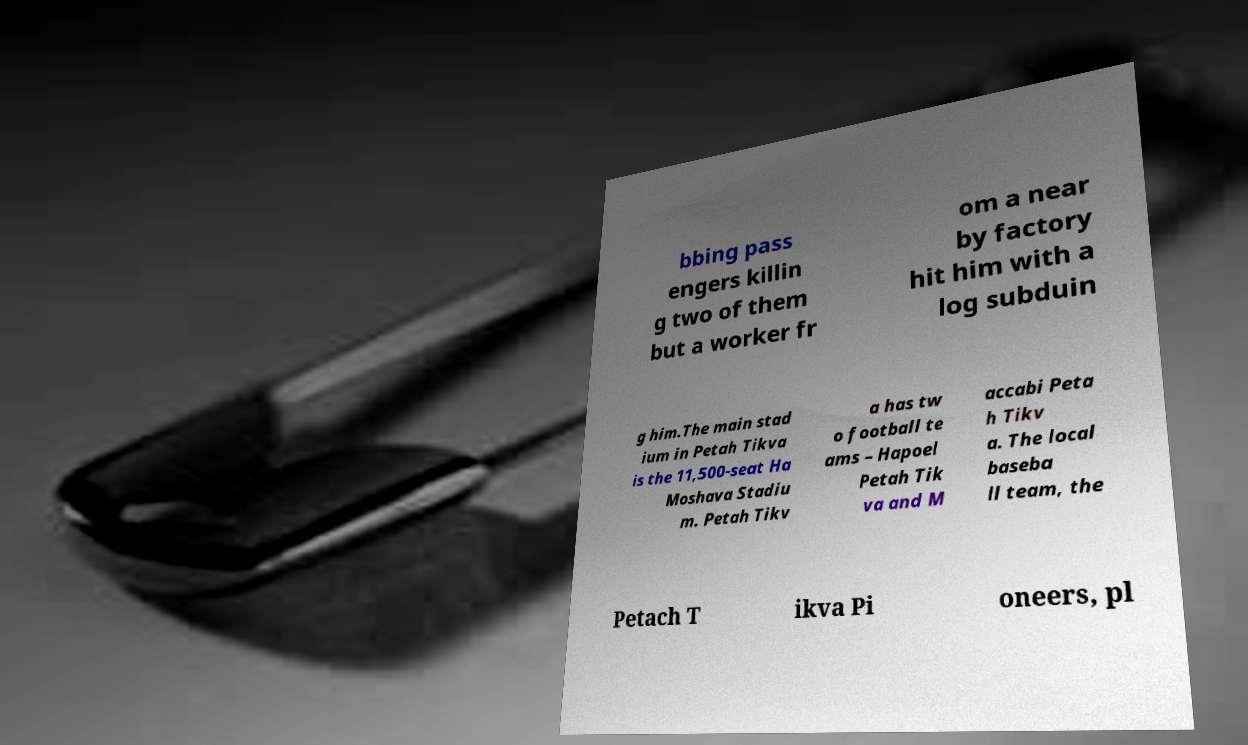What messages or text are displayed in this image? I need them in a readable, typed format. bbing pass engers killin g two of them but a worker fr om a near by factory hit him with a log subduin g him.The main stad ium in Petah Tikva is the 11,500-seat Ha Moshava Stadiu m. Petah Tikv a has tw o football te ams – Hapoel Petah Tik va and M accabi Peta h Tikv a. The local baseba ll team, the Petach T ikva Pi oneers, pl 